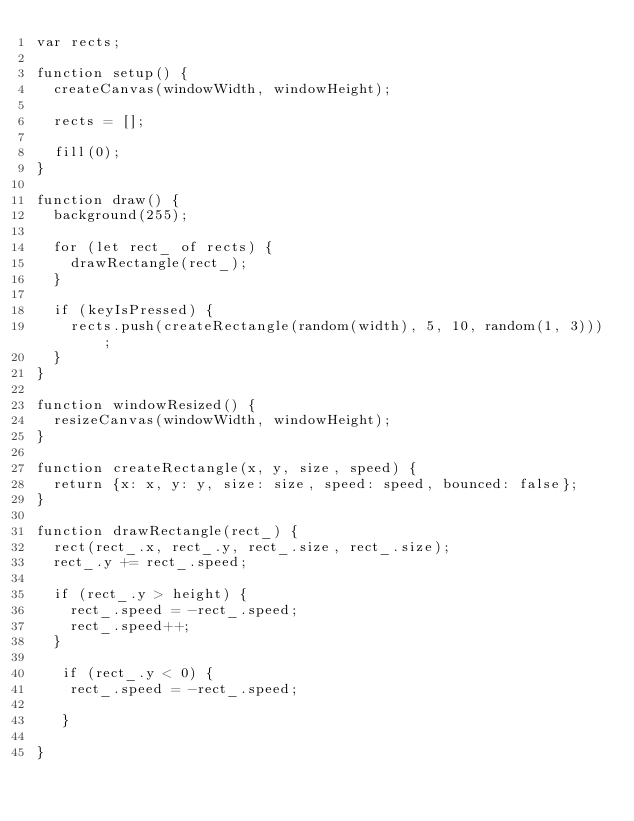<code> <loc_0><loc_0><loc_500><loc_500><_JavaScript_>var rects;

function setup() {
  createCanvas(windowWidth, windowHeight);

  rects = [];

  fill(0);
}

function draw() {
  background(255);

  for (let rect_ of rects) {
    drawRectangle(rect_);
  }

  if (keyIsPressed) {
    rects.push(createRectangle(random(width), 5, 10, random(1, 3)));
  }
}

function windowResized() {
  resizeCanvas(windowWidth, windowHeight);
}

function createRectangle(x, y, size, speed) {
  return {x: x, y: y, size: size, speed: speed, bounced: false};
}

function drawRectangle(rect_) {
  rect(rect_.x, rect_.y, rect_.size, rect_.size);
  rect_.y += rect_.speed;

  if (rect_.y > height) {
    rect_.speed = -rect_.speed;
    rect_.speed++;
  }
  
   if (rect_.y < 0) {
    rect_.speed = -rect_.speed;

   }
   
}</code> 